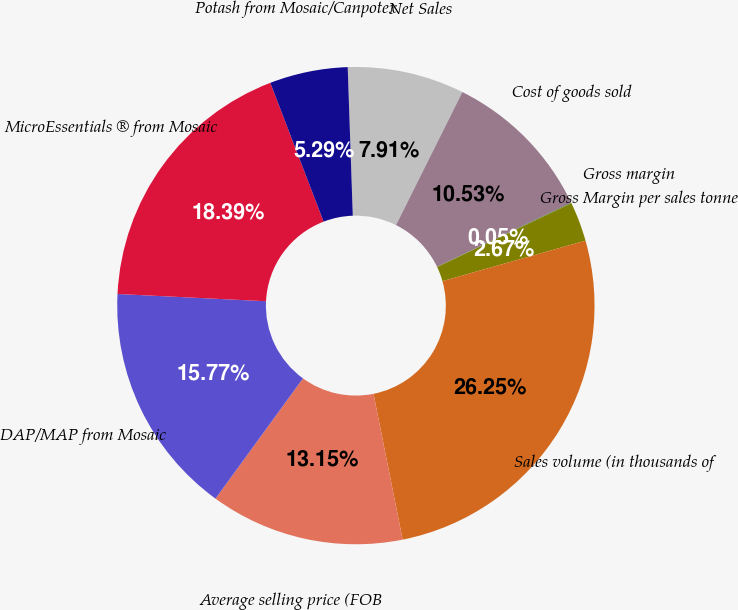<chart> <loc_0><loc_0><loc_500><loc_500><pie_chart><fcel>Net Sales<fcel>Cost of goods sold<fcel>Gross margin<fcel>Gross Margin per sales tonne<fcel>Sales volume (in thousands of<fcel>Average selling price (FOB<fcel>DAP/MAP from Mosaic<fcel>MicroEssentials ® from Mosaic<fcel>Potash from Mosaic/Canpotex<nl><fcel>7.91%<fcel>10.53%<fcel>0.05%<fcel>2.67%<fcel>26.25%<fcel>13.15%<fcel>15.77%<fcel>18.39%<fcel>5.29%<nl></chart> 